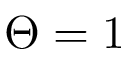Convert formula to latex. <formula><loc_0><loc_0><loc_500><loc_500>\Theta = 1</formula> 